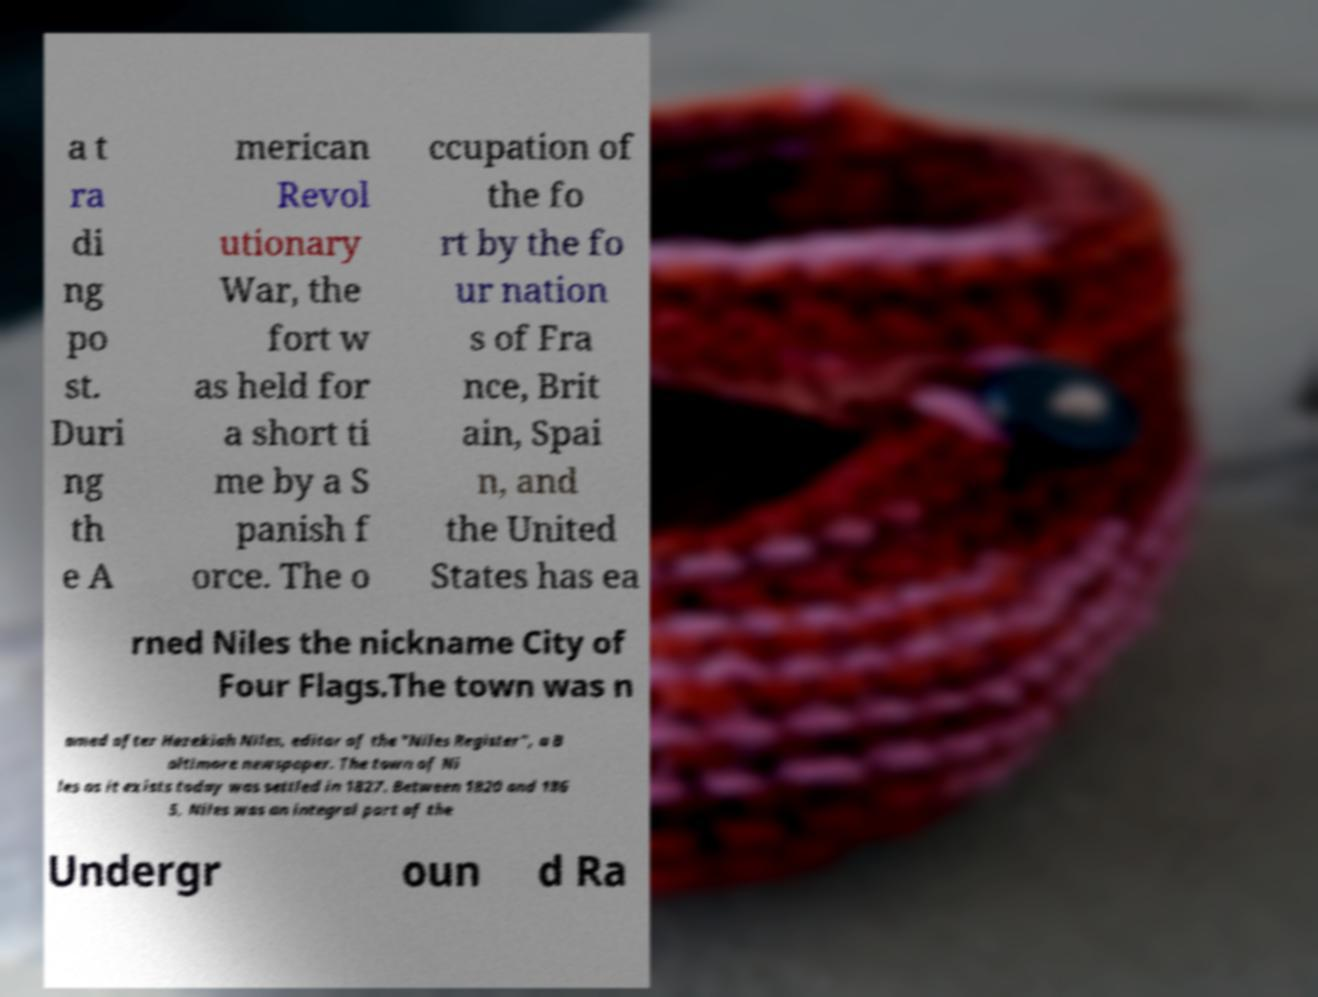Can you read and provide the text displayed in the image?This photo seems to have some interesting text. Can you extract and type it out for me? a t ra di ng po st. Duri ng th e A merican Revol utionary War, the fort w as held for a short ti me by a S panish f orce. The o ccupation of the fo rt by the fo ur nation s of Fra nce, Brit ain, Spai n, and the United States has ea rned Niles the nickname City of Four Flags.The town was n amed after Hezekiah Niles, editor of the "Niles Register", a B altimore newspaper. The town of Ni les as it exists today was settled in 1827. Between 1820 and 186 5, Niles was an integral part of the Undergr oun d Ra 